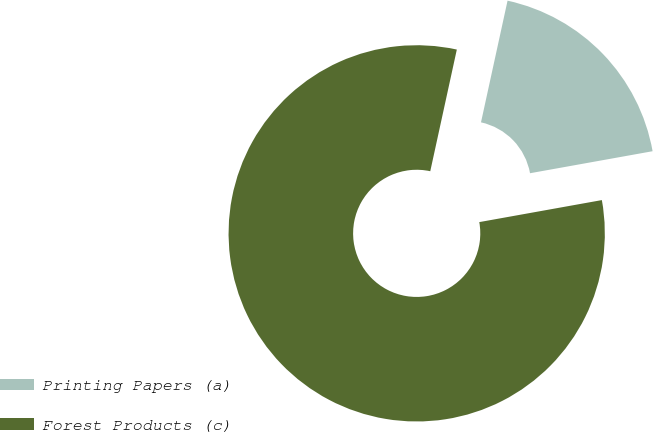Convert chart to OTSL. <chart><loc_0><loc_0><loc_500><loc_500><pie_chart><fcel>Printing Papers (a)<fcel>Forest Products (c)<nl><fcel>18.75%<fcel>81.25%<nl></chart> 